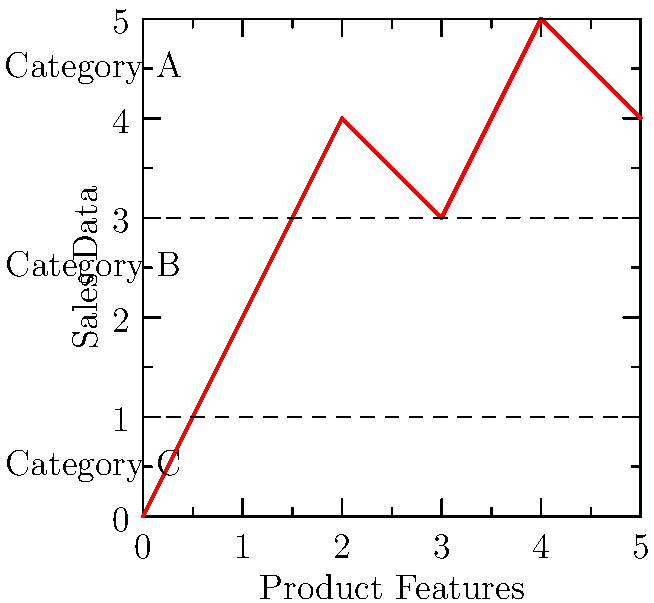Based on the dendrogram of product features and sales data shown in the graph, how many distinct product categories can be identified, and what strategy would you recommend to maximize sales across these segments? To answer this question, let's analyze the graph step-by-step:

1. Observe the graph: The x-axis represents product features, while the y-axis represents sales data.

2. Identify clusters: The graph shows three distinct horizontal bands or clusters.

3. Count categories: There are three clear categories, separated by dashed lines:
   - Category A: Above the top dashed line
   - Category B: Between the two dashed lines
   - Category C: Below the bottom dashed line

4. Analyze sales performance:
   - Category A products have the highest sales
   - Category B products have moderate sales
   - Category C products have the lowest sales

5. Strategy recommendation:
   a) Focus on promoting Category A products, as they are the best performers
   b) Investigate the features of Category A products to understand their success
   c) Attempt to improve Category B products by incorporating successful features from Category A
   d) Consider phasing out or redesigning Category C products to boost their performance

6. Sales maximization approach:
   - Allocate more resources to marketing and distribution of Category A products
   - Develop targeted sales strategies for each category
   - Cross-sell Category B products with Category A products to increase overall sales
   - Use the success of Category A products to negotiate better terms with suppliers and ensure prompt deliveries

By segmenting products and tailoring strategies to each category, a resourceful sales representative can maximize sales across all segments while focusing on the most profitable products.
Answer: 3 categories; focus on Category A, improve B, redesign C 